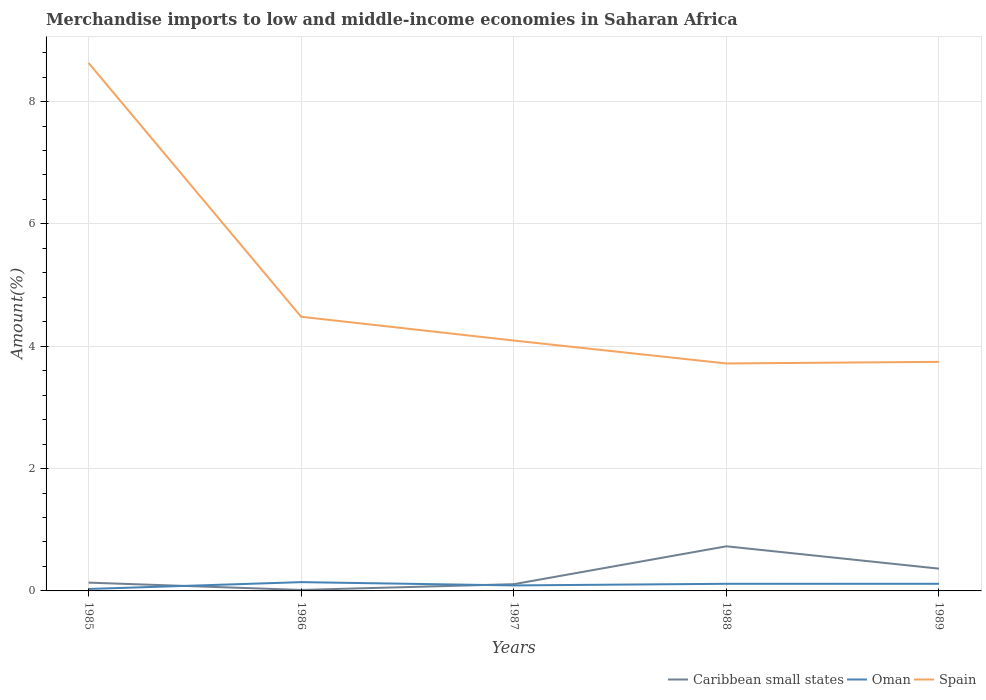How many different coloured lines are there?
Provide a short and direct response. 3. Does the line corresponding to Spain intersect with the line corresponding to Caribbean small states?
Provide a short and direct response. No. Across all years, what is the maximum percentage of amount earned from merchandise imports in Caribbean small states?
Your response must be concise. 0.02. In which year was the percentage of amount earned from merchandise imports in Caribbean small states maximum?
Ensure brevity in your answer.  1986. What is the total percentage of amount earned from merchandise imports in Spain in the graph?
Your answer should be compact. 4.54. What is the difference between the highest and the second highest percentage of amount earned from merchandise imports in Caribbean small states?
Give a very brief answer. 0.71. How many years are there in the graph?
Provide a succinct answer. 5. Does the graph contain any zero values?
Give a very brief answer. No. Does the graph contain grids?
Make the answer very short. Yes. Where does the legend appear in the graph?
Offer a very short reply. Bottom right. What is the title of the graph?
Offer a terse response. Merchandise imports to low and middle-income economies in Saharan Africa. Does "Spain" appear as one of the legend labels in the graph?
Make the answer very short. Yes. What is the label or title of the Y-axis?
Your answer should be compact. Amount(%). What is the Amount(%) of Caribbean small states in 1985?
Your response must be concise. 0.14. What is the Amount(%) in Oman in 1985?
Make the answer very short. 0.03. What is the Amount(%) in Spain in 1985?
Offer a terse response. 8.63. What is the Amount(%) in Caribbean small states in 1986?
Offer a very short reply. 0.02. What is the Amount(%) of Oman in 1986?
Give a very brief answer. 0.14. What is the Amount(%) in Spain in 1986?
Your answer should be very brief. 4.48. What is the Amount(%) in Caribbean small states in 1987?
Ensure brevity in your answer.  0.11. What is the Amount(%) in Oman in 1987?
Ensure brevity in your answer.  0.09. What is the Amount(%) of Spain in 1987?
Your answer should be very brief. 4.09. What is the Amount(%) of Caribbean small states in 1988?
Make the answer very short. 0.73. What is the Amount(%) in Oman in 1988?
Provide a short and direct response. 0.12. What is the Amount(%) of Spain in 1988?
Provide a short and direct response. 3.72. What is the Amount(%) of Caribbean small states in 1989?
Keep it short and to the point. 0.36. What is the Amount(%) in Oman in 1989?
Ensure brevity in your answer.  0.12. What is the Amount(%) of Spain in 1989?
Offer a very short reply. 3.74. Across all years, what is the maximum Amount(%) of Caribbean small states?
Your response must be concise. 0.73. Across all years, what is the maximum Amount(%) of Oman?
Offer a very short reply. 0.14. Across all years, what is the maximum Amount(%) in Spain?
Offer a terse response. 8.63. Across all years, what is the minimum Amount(%) in Caribbean small states?
Make the answer very short. 0.02. Across all years, what is the minimum Amount(%) of Oman?
Provide a short and direct response. 0.03. Across all years, what is the minimum Amount(%) in Spain?
Your answer should be very brief. 3.72. What is the total Amount(%) of Caribbean small states in the graph?
Your answer should be very brief. 1.36. What is the total Amount(%) of Oman in the graph?
Keep it short and to the point. 0.5. What is the total Amount(%) in Spain in the graph?
Make the answer very short. 24.67. What is the difference between the Amount(%) of Caribbean small states in 1985 and that in 1986?
Give a very brief answer. 0.12. What is the difference between the Amount(%) in Oman in 1985 and that in 1986?
Make the answer very short. -0.11. What is the difference between the Amount(%) in Spain in 1985 and that in 1986?
Offer a very short reply. 4.15. What is the difference between the Amount(%) of Caribbean small states in 1985 and that in 1987?
Your answer should be very brief. 0.03. What is the difference between the Amount(%) of Oman in 1985 and that in 1987?
Keep it short and to the point. -0.06. What is the difference between the Amount(%) in Spain in 1985 and that in 1987?
Your answer should be compact. 4.54. What is the difference between the Amount(%) of Caribbean small states in 1985 and that in 1988?
Your response must be concise. -0.59. What is the difference between the Amount(%) in Oman in 1985 and that in 1988?
Provide a succinct answer. -0.08. What is the difference between the Amount(%) of Spain in 1985 and that in 1988?
Provide a succinct answer. 4.91. What is the difference between the Amount(%) of Caribbean small states in 1985 and that in 1989?
Offer a terse response. -0.23. What is the difference between the Amount(%) of Oman in 1985 and that in 1989?
Offer a very short reply. -0.09. What is the difference between the Amount(%) in Spain in 1985 and that in 1989?
Your answer should be very brief. 4.89. What is the difference between the Amount(%) of Caribbean small states in 1986 and that in 1987?
Offer a terse response. -0.09. What is the difference between the Amount(%) of Oman in 1986 and that in 1987?
Ensure brevity in your answer.  0.05. What is the difference between the Amount(%) in Spain in 1986 and that in 1987?
Provide a succinct answer. 0.39. What is the difference between the Amount(%) in Caribbean small states in 1986 and that in 1988?
Keep it short and to the point. -0.71. What is the difference between the Amount(%) of Oman in 1986 and that in 1988?
Give a very brief answer. 0.03. What is the difference between the Amount(%) in Spain in 1986 and that in 1988?
Make the answer very short. 0.76. What is the difference between the Amount(%) in Caribbean small states in 1986 and that in 1989?
Provide a short and direct response. -0.35. What is the difference between the Amount(%) in Oman in 1986 and that in 1989?
Your answer should be very brief. 0.03. What is the difference between the Amount(%) in Spain in 1986 and that in 1989?
Provide a short and direct response. 0.74. What is the difference between the Amount(%) of Caribbean small states in 1987 and that in 1988?
Offer a terse response. -0.62. What is the difference between the Amount(%) of Oman in 1987 and that in 1988?
Your answer should be compact. -0.03. What is the difference between the Amount(%) in Spain in 1987 and that in 1988?
Give a very brief answer. 0.37. What is the difference between the Amount(%) in Caribbean small states in 1987 and that in 1989?
Make the answer very short. -0.25. What is the difference between the Amount(%) of Oman in 1987 and that in 1989?
Keep it short and to the point. -0.03. What is the difference between the Amount(%) of Spain in 1987 and that in 1989?
Offer a very short reply. 0.35. What is the difference between the Amount(%) of Caribbean small states in 1988 and that in 1989?
Your answer should be very brief. 0.37. What is the difference between the Amount(%) in Oman in 1988 and that in 1989?
Provide a short and direct response. -0. What is the difference between the Amount(%) in Spain in 1988 and that in 1989?
Offer a terse response. -0.03. What is the difference between the Amount(%) in Caribbean small states in 1985 and the Amount(%) in Oman in 1986?
Offer a terse response. -0.01. What is the difference between the Amount(%) in Caribbean small states in 1985 and the Amount(%) in Spain in 1986?
Provide a short and direct response. -4.35. What is the difference between the Amount(%) in Oman in 1985 and the Amount(%) in Spain in 1986?
Make the answer very short. -4.45. What is the difference between the Amount(%) in Caribbean small states in 1985 and the Amount(%) in Oman in 1987?
Ensure brevity in your answer.  0.05. What is the difference between the Amount(%) of Caribbean small states in 1985 and the Amount(%) of Spain in 1987?
Offer a very short reply. -3.96. What is the difference between the Amount(%) of Oman in 1985 and the Amount(%) of Spain in 1987?
Keep it short and to the point. -4.06. What is the difference between the Amount(%) of Caribbean small states in 1985 and the Amount(%) of Oman in 1988?
Provide a short and direct response. 0.02. What is the difference between the Amount(%) in Caribbean small states in 1985 and the Amount(%) in Spain in 1988?
Your response must be concise. -3.58. What is the difference between the Amount(%) in Oman in 1985 and the Amount(%) in Spain in 1988?
Give a very brief answer. -3.69. What is the difference between the Amount(%) in Caribbean small states in 1985 and the Amount(%) in Oman in 1989?
Provide a succinct answer. 0.02. What is the difference between the Amount(%) of Caribbean small states in 1985 and the Amount(%) of Spain in 1989?
Provide a short and direct response. -3.61. What is the difference between the Amount(%) of Oman in 1985 and the Amount(%) of Spain in 1989?
Provide a short and direct response. -3.71. What is the difference between the Amount(%) of Caribbean small states in 1986 and the Amount(%) of Oman in 1987?
Offer a terse response. -0.07. What is the difference between the Amount(%) of Caribbean small states in 1986 and the Amount(%) of Spain in 1987?
Keep it short and to the point. -4.08. What is the difference between the Amount(%) in Oman in 1986 and the Amount(%) in Spain in 1987?
Provide a short and direct response. -3.95. What is the difference between the Amount(%) in Caribbean small states in 1986 and the Amount(%) in Oman in 1988?
Keep it short and to the point. -0.1. What is the difference between the Amount(%) of Caribbean small states in 1986 and the Amount(%) of Spain in 1988?
Your answer should be compact. -3.7. What is the difference between the Amount(%) of Oman in 1986 and the Amount(%) of Spain in 1988?
Provide a succinct answer. -3.57. What is the difference between the Amount(%) of Caribbean small states in 1986 and the Amount(%) of Oman in 1989?
Your answer should be compact. -0.1. What is the difference between the Amount(%) of Caribbean small states in 1986 and the Amount(%) of Spain in 1989?
Offer a very short reply. -3.73. What is the difference between the Amount(%) of Oman in 1986 and the Amount(%) of Spain in 1989?
Give a very brief answer. -3.6. What is the difference between the Amount(%) in Caribbean small states in 1987 and the Amount(%) in Oman in 1988?
Your response must be concise. -0.01. What is the difference between the Amount(%) in Caribbean small states in 1987 and the Amount(%) in Spain in 1988?
Offer a terse response. -3.61. What is the difference between the Amount(%) of Oman in 1987 and the Amount(%) of Spain in 1988?
Provide a short and direct response. -3.63. What is the difference between the Amount(%) in Caribbean small states in 1987 and the Amount(%) in Oman in 1989?
Provide a succinct answer. -0.01. What is the difference between the Amount(%) of Caribbean small states in 1987 and the Amount(%) of Spain in 1989?
Your answer should be compact. -3.63. What is the difference between the Amount(%) in Oman in 1987 and the Amount(%) in Spain in 1989?
Your answer should be compact. -3.65. What is the difference between the Amount(%) of Caribbean small states in 1988 and the Amount(%) of Oman in 1989?
Your answer should be very brief. 0.61. What is the difference between the Amount(%) in Caribbean small states in 1988 and the Amount(%) in Spain in 1989?
Your answer should be very brief. -3.02. What is the difference between the Amount(%) of Oman in 1988 and the Amount(%) of Spain in 1989?
Provide a short and direct response. -3.63. What is the average Amount(%) in Caribbean small states per year?
Ensure brevity in your answer.  0.27. What is the average Amount(%) in Oman per year?
Give a very brief answer. 0.1. What is the average Amount(%) of Spain per year?
Offer a very short reply. 4.93. In the year 1985, what is the difference between the Amount(%) in Caribbean small states and Amount(%) in Oman?
Your answer should be very brief. 0.1. In the year 1985, what is the difference between the Amount(%) of Caribbean small states and Amount(%) of Spain?
Give a very brief answer. -8.5. In the year 1985, what is the difference between the Amount(%) in Oman and Amount(%) in Spain?
Offer a terse response. -8.6. In the year 1986, what is the difference between the Amount(%) of Caribbean small states and Amount(%) of Oman?
Your response must be concise. -0.13. In the year 1986, what is the difference between the Amount(%) in Caribbean small states and Amount(%) in Spain?
Your response must be concise. -4.47. In the year 1986, what is the difference between the Amount(%) of Oman and Amount(%) of Spain?
Ensure brevity in your answer.  -4.34. In the year 1987, what is the difference between the Amount(%) in Caribbean small states and Amount(%) in Oman?
Keep it short and to the point. 0.02. In the year 1987, what is the difference between the Amount(%) of Caribbean small states and Amount(%) of Spain?
Your response must be concise. -3.98. In the year 1987, what is the difference between the Amount(%) in Oman and Amount(%) in Spain?
Provide a short and direct response. -4. In the year 1988, what is the difference between the Amount(%) of Caribbean small states and Amount(%) of Oman?
Give a very brief answer. 0.61. In the year 1988, what is the difference between the Amount(%) in Caribbean small states and Amount(%) in Spain?
Provide a succinct answer. -2.99. In the year 1988, what is the difference between the Amount(%) of Oman and Amount(%) of Spain?
Provide a short and direct response. -3.6. In the year 1989, what is the difference between the Amount(%) of Caribbean small states and Amount(%) of Oman?
Your answer should be very brief. 0.25. In the year 1989, what is the difference between the Amount(%) of Caribbean small states and Amount(%) of Spain?
Your answer should be compact. -3.38. In the year 1989, what is the difference between the Amount(%) of Oman and Amount(%) of Spain?
Give a very brief answer. -3.63. What is the ratio of the Amount(%) of Caribbean small states in 1985 to that in 1986?
Your response must be concise. 8.45. What is the ratio of the Amount(%) of Oman in 1985 to that in 1986?
Your response must be concise. 0.22. What is the ratio of the Amount(%) in Spain in 1985 to that in 1986?
Your response must be concise. 1.93. What is the ratio of the Amount(%) in Caribbean small states in 1985 to that in 1987?
Offer a very short reply. 1.23. What is the ratio of the Amount(%) of Oman in 1985 to that in 1987?
Keep it short and to the point. 0.35. What is the ratio of the Amount(%) of Spain in 1985 to that in 1987?
Make the answer very short. 2.11. What is the ratio of the Amount(%) in Caribbean small states in 1985 to that in 1988?
Offer a terse response. 0.19. What is the ratio of the Amount(%) of Oman in 1985 to that in 1988?
Your answer should be compact. 0.27. What is the ratio of the Amount(%) of Spain in 1985 to that in 1988?
Make the answer very short. 2.32. What is the ratio of the Amount(%) of Caribbean small states in 1985 to that in 1989?
Your response must be concise. 0.37. What is the ratio of the Amount(%) in Oman in 1985 to that in 1989?
Give a very brief answer. 0.27. What is the ratio of the Amount(%) in Spain in 1985 to that in 1989?
Offer a terse response. 2.31. What is the ratio of the Amount(%) of Caribbean small states in 1986 to that in 1987?
Your response must be concise. 0.15. What is the ratio of the Amount(%) in Oman in 1986 to that in 1987?
Give a very brief answer. 1.6. What is the ratio of the Amount(%) of Spain in 1986 to that in 1987?
Your answer should be compact. 1.09. What is the ratio of the Amount(%) in Caribbean small states in 1986 to that in 1988?
Your response must be concise. 0.02. What is the ratio of the Amount(%) of Oman in 1986 to that in 1988?
Keep it short and to the point. 1.23. What is the ratio of the Amount(%) of Spain in 1986 to that in 1988?
Your response must be concise. 1.21. What is the ratio of the Amount(%) of Caribbean small states in 1986 to that in 1989?
Make the answer very short. 0.04. What is the ratio of the Amount(%) of Oman in 1986 to that in 1989?
Provide a short and direct response. 1.23. What is the ratio of the Amount(%) of Spain in 1986 to that in 1989?
Provide a succinct answer. 1.2. What is the ratio of the Amount(%) of Caribbean small states in 1987 to that in 1988?
Offer a terse response. 0.15. What is the ratio of the Amount(%) in Oman in 1987 to that in 1988?
Ensure brevity in your answer.  0.77. What is the ratio of the Amount(%) of Spain in 1987 to that in 1988?
Provide a short and direct response. 1.1. What is the ratio of the Amount(%) of Caribbean small states in 1987 to that in 1989?
Make the answer very short. 0.3. What is the ratio of the Amount(%) in Oman in 1987 to that in 1989?
Provide a succinct answer. 0.77. What is the ratio of the Amount(%) in Spain in 1987 to that in 1989?
Ensure brevity in your answer.  1.09. What is the ratio of the Amount(%) of Caribbean small states in 1988 to that in 1989?
Make the answer very short. 2. What is the ratio of the Amount(%) of Oman in 1988 to that in 1989?
Ensure brevity in your answer.  1. What is the difference between the highest and the second highest Amount(%) of Caribbean small states?
Keep it short and to the point. 0.37. What is the difference between the highest and the second highest Amount(%) in Oman?
Ensure brevity in your answer.  0.03. What is the difference between the highest and the second highest Amount(%) of Spain?
Keep it short and to the point. 4.15. What is the difference between the highest and the lowest Amount(%) in Caribbean small states?
Your answer should be very brief. 0.71. What is the difference between the highest and the lowest Amount(%) in Oman?
Your response must be concise. 0.11. What is the difference between the highest and the lowest Amount(%) of Spain?
Keep it short and to the point. 4.91. 